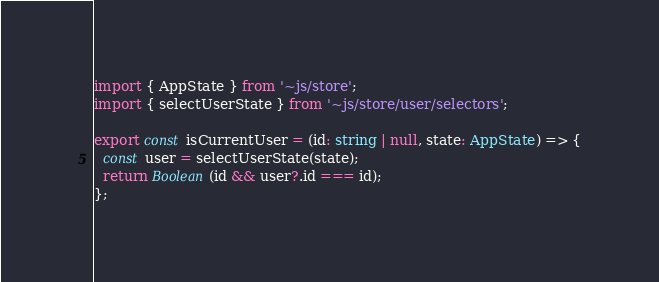Convert code to text. <code><loc_0><loc_0><loc_500><loc_500><_TypeScript_>import { AppState } from '~js/store';
import { selectUserState } from '~js/store/user/selectors';

export const isCurrentUser = (id: string | null, state: AppState) => {
  const user = selectUserState(state);
  return Boolean(id && user?.id === id);
};
</code> 